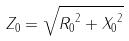Convert formula to latex. <formula><loc_0><loc_0><loc_500><loc_500>Z _ { 0 } = \sqrt { { R _ { 0 } } ^ { 2 } + { X _ { 0 } } ^ { 2 } }</formula> 